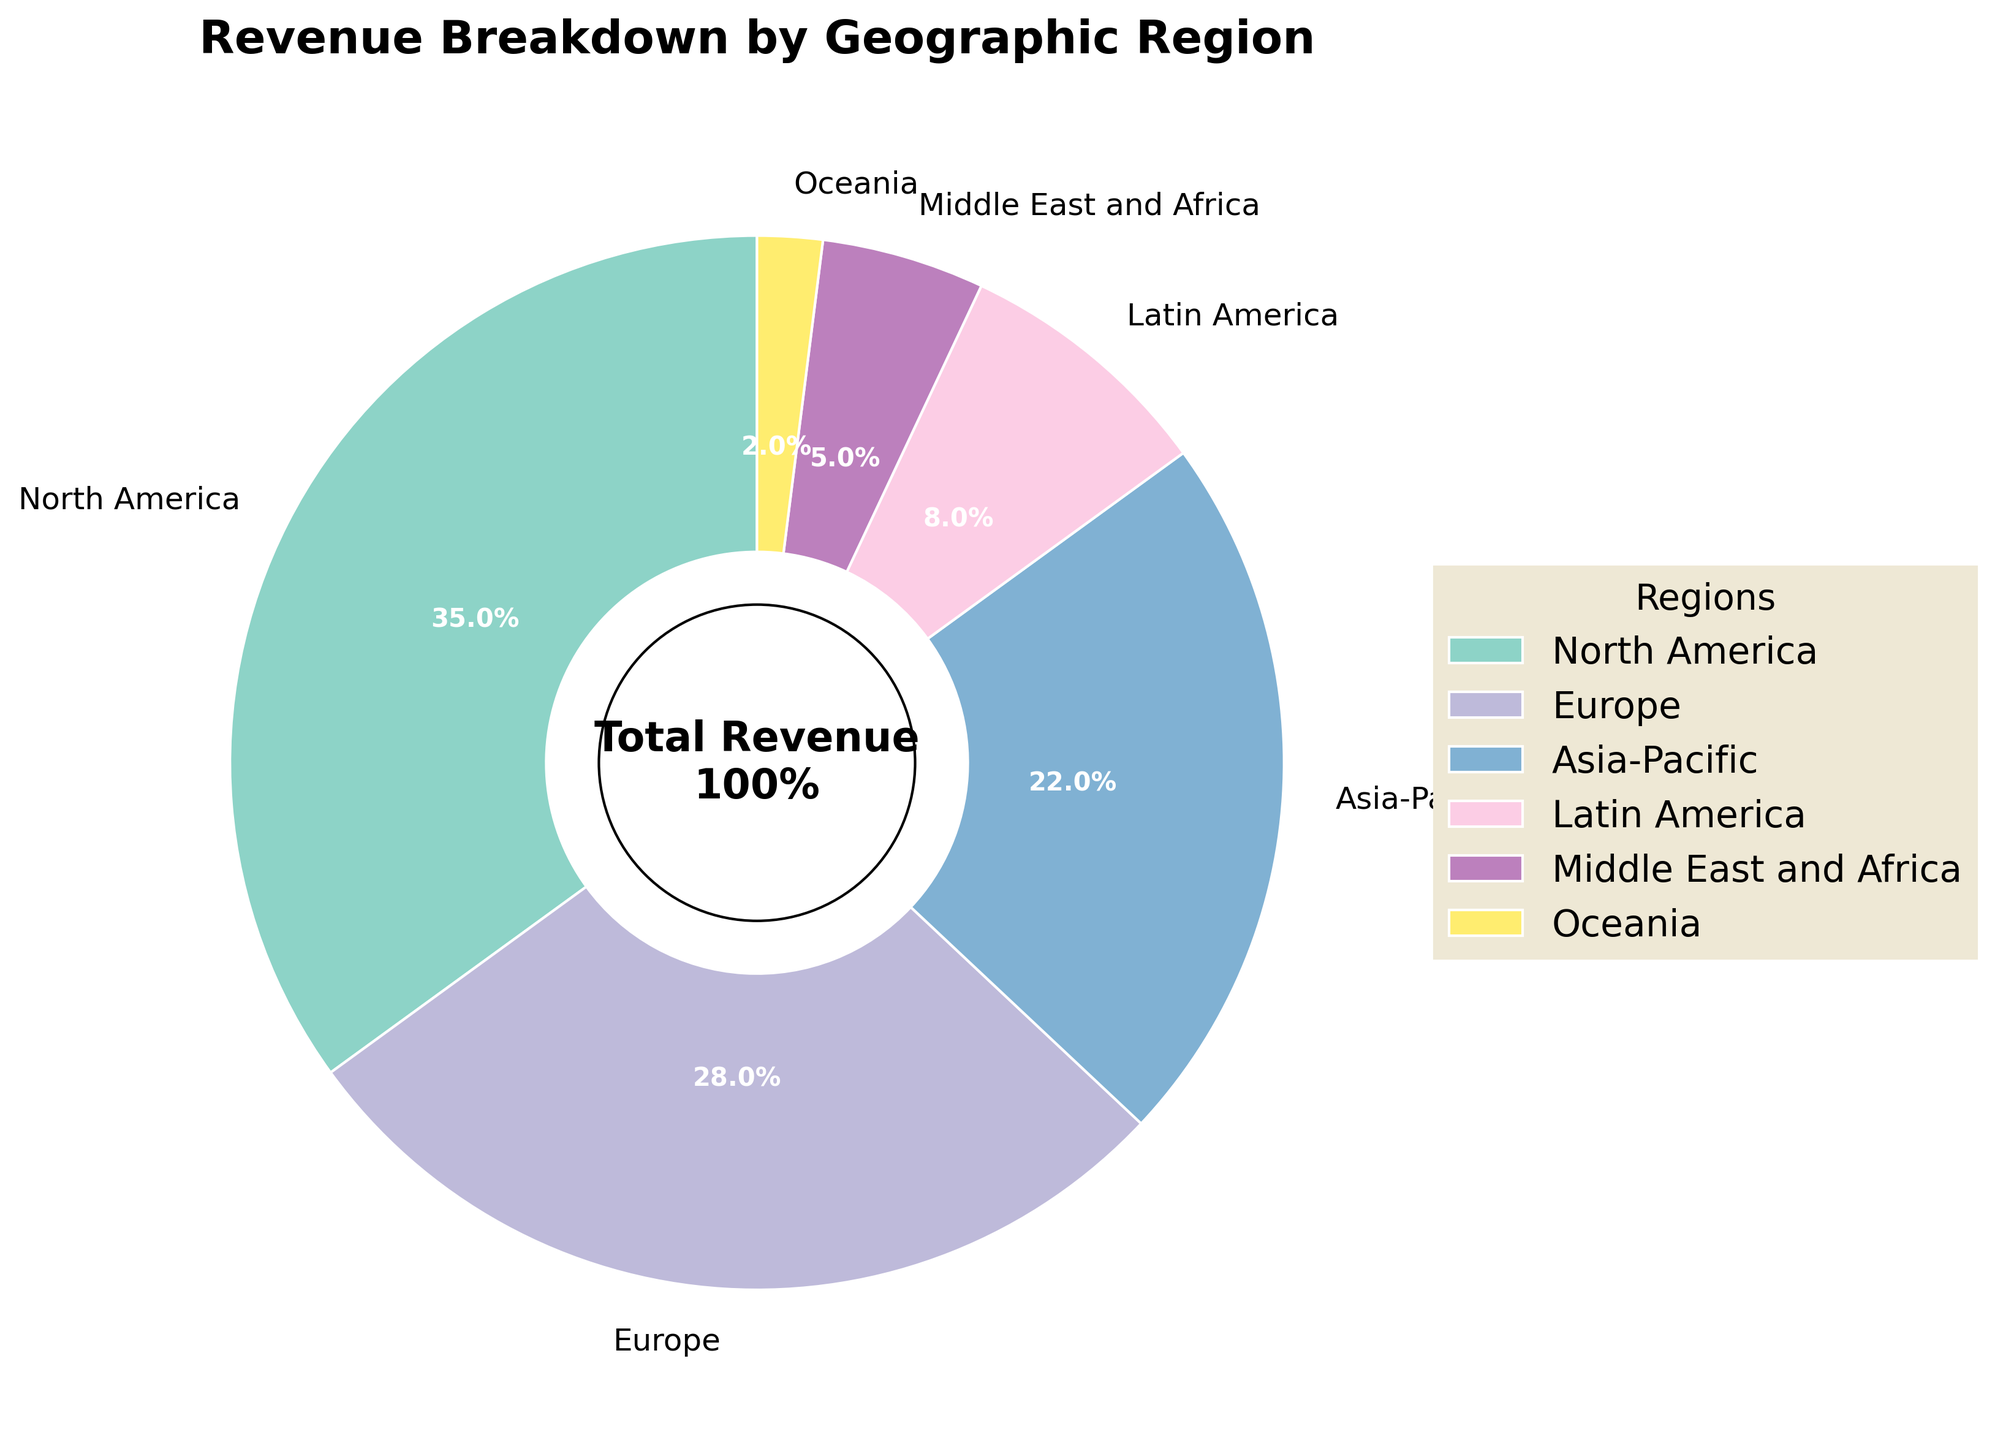What region contributes the most to revenue? The pie chart shows that North America has the largest wedge, labeled with 35%. Therefore, North America contributes the most to revenue.
Answer: North America What percentage of the total revenue comes from Europe and Asia-Pacific combined? The pie chart labels Europe with 28% and Asia-Pacific with 22%. Adding these percentages, 28% + 22% = 50%.
Answer: 50% How much more revenue does North America generate compared to Latin America? North America has a revenue of 35%, while Latin America has 8%. The difference is 35% - 8% = 27%.
Answer: 27% Which regions collectively contribute to more than half of the total revenue? North America (35%), Europe (28%), and Asia-Pacific (22%) are the possible candidates. Summing their contributions: 35% + 28% + 22% = 85%, which is more than half. Hence, these regions collectively contribute more than half.
Answer: North America, Europe, Asia-Pacific Which region contributes the least to revenue? The pie chart shows that Oceania has the smallest wedge, labeled with 2%. Therefore, Oceania contributes the least to revenue.
Answer: Oceania Is the revenue contributed by the Middle East and Africa greater than that by Oceania? The pie chart labels the Middle East and Africa with 5% and Oceania with 2%. Since 5% is greater than 2%, the revenue from the Middle East and Africa is greater.
Answer: Yes What is the combined revenue contribution of Latin America and the Middle East and Africa? The pie chart labels Latin America with 8% and the Middle East and Africa with 5%. Adding these values, 8% + 5% = 13%.
Answer: 13% How does the revenue from Latin America compare to that from Asia-Pacific? Latin America is labeled with 8% while Asia-Pacific is labeled with 22%. Since 8% is less than 22%, Latin America's revenue is less.
Answer: Less What is the median revenue contribution among the regions? Listing the regions by their revenue contributions: 2% (Oceania), 5% (Middle East and Africa), 8% (Latin America), 22% (Asia-Pacific), 28% (Europe), and 35% (North America). The median is the average of the middle two values in this sorted list: (8% + 22%) / 2 = 15%.
Answer: 15% What proportion of the total revenue comes from regions outside of North America, Europe, and Asia-Pacific? North America, Europe, and Asia-Pacific contribute 35%, 28%, and 22% respectively. Their total is 35% + 28% + 22% = 85%. Therefore, the proportion from other regions is 100% - 85% = 15%.
Answer: 15% 